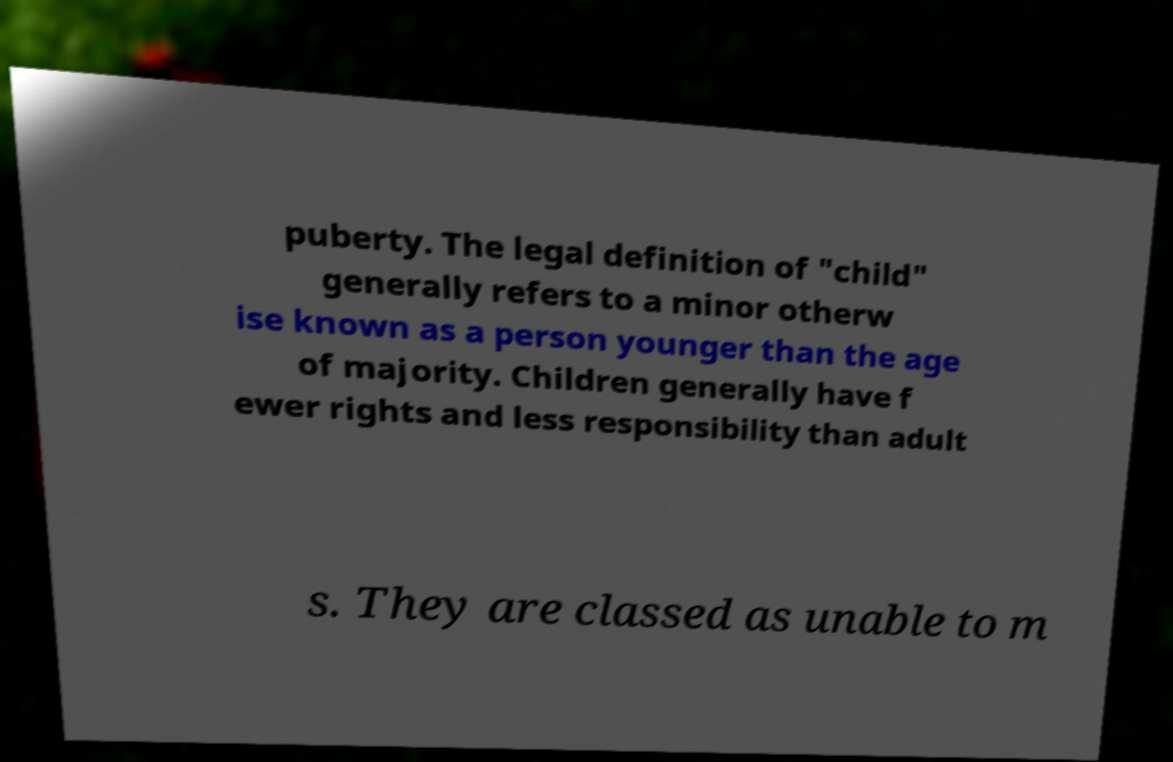Could you assist in decoding the text presented in this image and type it out clearly? puberty. The legal definition of "child" generally refers to a minor otherw ise known as a person younger than the age of majority. Children generally have f ewer rights and less responsibility than adult s. They are classed as unable to m 